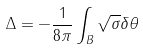Convert formula to latex. <formula><loc_0><loc_0><loc_500><loc_500>\Delta = - \frac { 1 } { 8 \pi } \int _ { B } \sqrt { \sigma } \delta \theta</formula> 